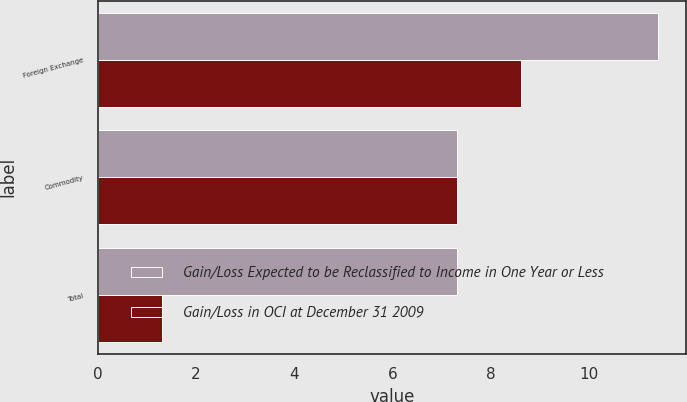Convert chart to OTSL. <chart><loc_0><loc_0><loc_500><loc_500><stacked_bar_chart><ecel><fcel>Foreign Exchange<fcel>Commodity<fcel>Total<nl><fcel>Gain/Loss Expected to be Reclassified to Income in One Year or Less<fcel>11.4<fcel>7.3<fcel>7.3<nl><fcel>Gain/Loss in OCI at December 31 2009<fcel>8.6<fcel>7.3<fcel>1.3<nl></chart> 